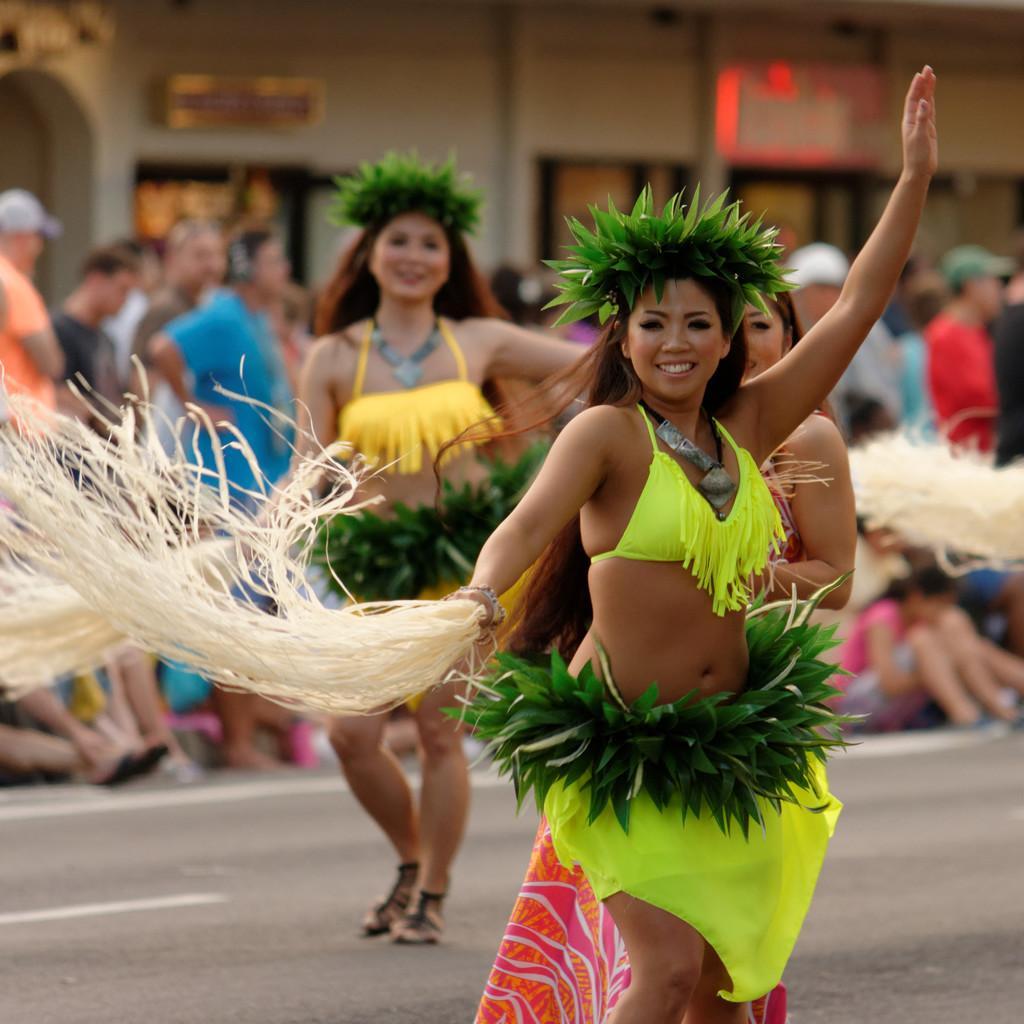Describe this image in one or two sentences. There are persons in different color dresses, smiling and dancing on the road on which, there are white color marks 